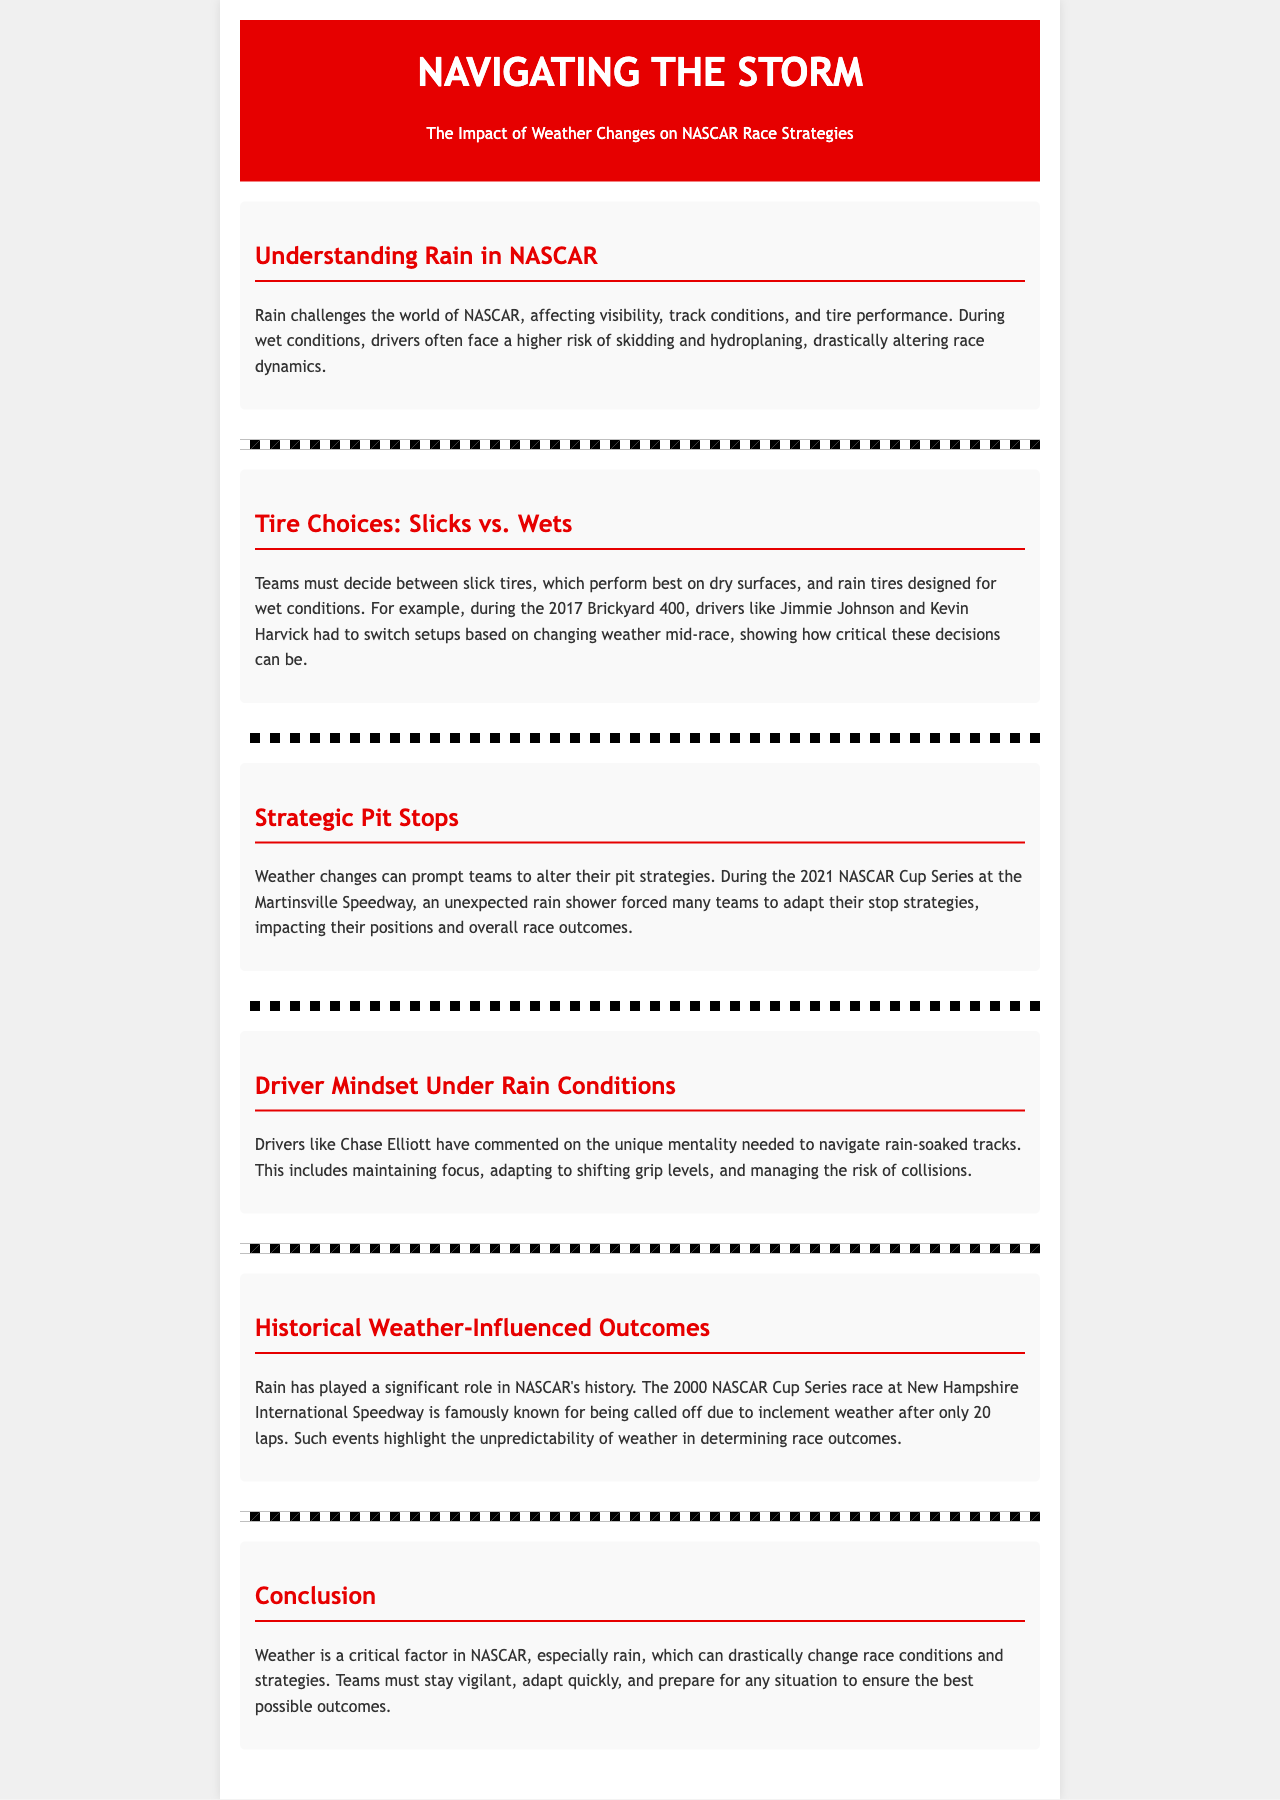What is the impact of rain on visibility? Rain challenges visibility and track conditions in NASCAR.
Answer: Visibility Which tire type is best for dry surfaces? Slick tires perform best on dry surfaces.
Answer: Slick tires Who had to switch setups during the 2017 Brickyard 400? Drivers like Jimmie Johnson and Kevin Harvick had to switch setups based on changing weather.
Answer: Jimmie Johnson and Kevin Harvick What year did the rain cause a race at New Hampshire to be called off? The 2000 NASCAR Cup Series race is famously known for being called off due to inclement weather.
Answer: 2000 What did Chase Elliott comment on? Chase Elliott commented on the unique mentality needed to navigate rain-soaked tracks.
Answer: Unique mentality How can weather changes prompt teams to alter their strategies? Weather changes can prompt teams to adapt their pit strategies during races.
Answer: Adapt their pit strategies What was a significant outcome of the 2021 NASCAR Cup Series at Martinsville? An unexpected rain shower forced many teams to adapt their stop strategies, impacting positions.
Answer: Adapting stop strategies What does the term "hydroplaning" refer to? Hydroplaning refers to losing traction during wet conditions, which is a risk for drivers.
Answer: Losing traction 